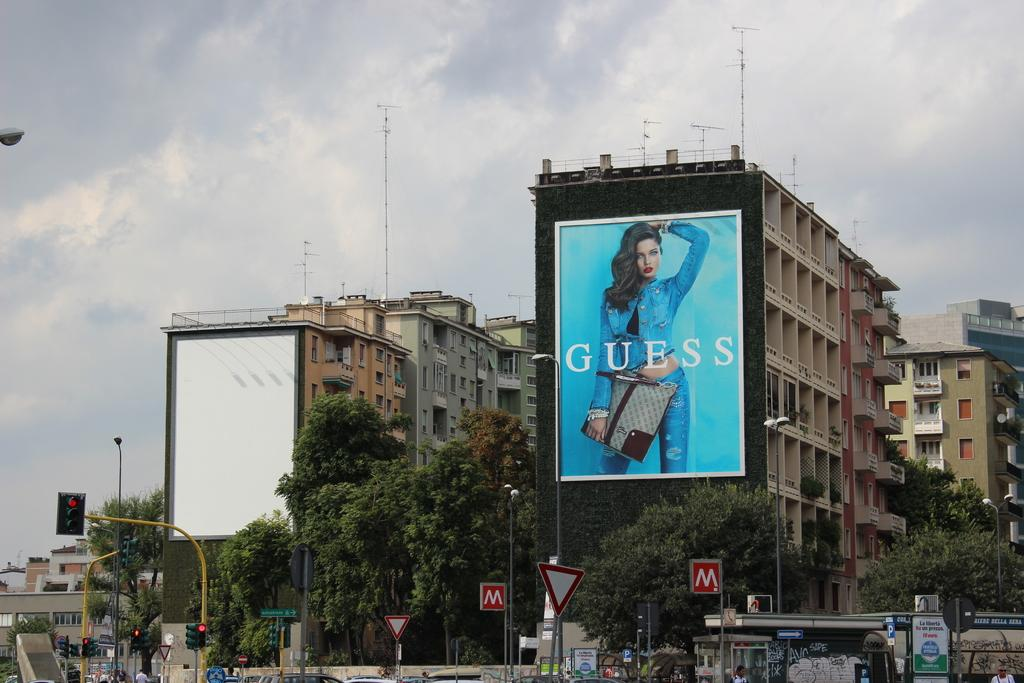<image>
Relay a brief, clear account of the picture shown. A large outdoor billboard for Guess on the side of a building. 